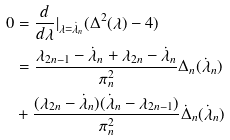<formula> <loc_0><loc_0><loc_500><loc_500>0 & = \frac { d } { d \lambda } | _ { \lambda = \dot { \lambda } _ { n } } ( \Delta ^ { 2 } ( \lambda ) - 4 ) \\ & = \frac { \lambda _ { 2 n - 1 } - \dot { \lambda } _ { n } + \lambda _ { 2 n } - \dot { \lambda } _ { n } } { \pi _ { n } ^ { 2 } } \Delta _ { n } ( \dot { \lambda } _ { n } ) \\ & + \frac { ( \lambda _ { 2 n } - \dot { \lambda } _ { n } ) ( \dot { \lambda } _ { n } - \lambda _ { 2 n - 1 } ) } { \pi _ { n } ^ { 2 } } \dot { \Delta } _ { n } ( \dot { \lambda } _ { n } )</formula> 